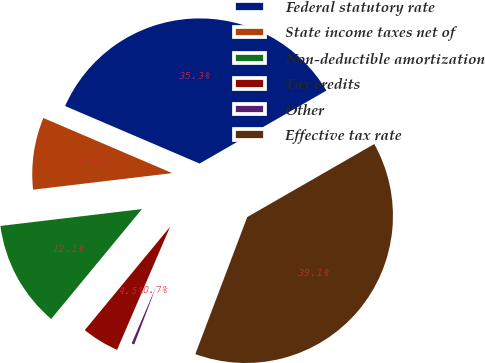<chart> <loc_0><loc_0><loc_500><loc_500><pie_chart><fcel>Federal statutory rate<fcel>State income taxes net of<fcel>Non-deductible amortization<fcel>Tax credits<fcel>Other<fcel>Effective tax rate<nl><fcel>35.26%<fcel>8.32%<fcel>12.13%<fcel>4.51%<fcel>0.71%<fcel>39.07%<nl></chart> 